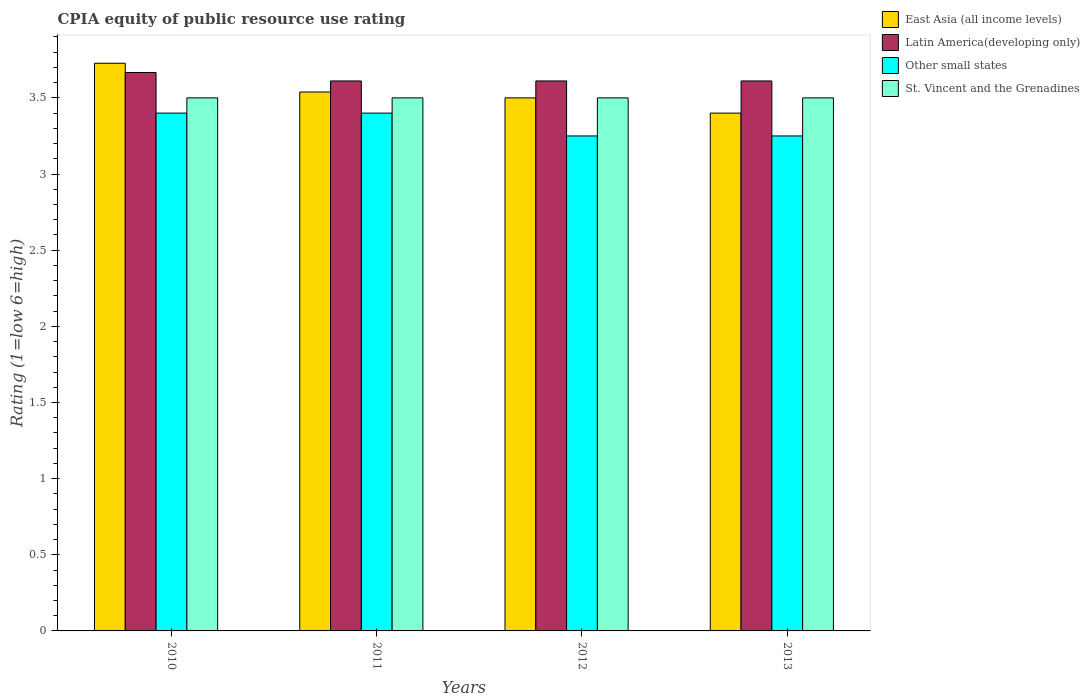How many different coloured bars are there?
Provide a short and direct response. 4. Are the number of bars per tick equal to the number of legend labels?
Provide a succinct answer. Yes. How many bars are there on the 3rd tick from the left?
Make the answer very short. 4. How many bars are there on the 2nd tick from the right?
Provide a short and direct response. 4. What is the CPIA rating in Latin America(developing only) in 2010?
Your response must be concise. 3.67. Across all years, what is the maximum CPIA rating in East Asia (all income levels)?
Provide a short and direct response. 3.73. Across all years, what is the minimum CPIA rating in Other small states?
Offer a very short reply. 3.25. In which year was the CPIA rating in St. Vincent and the Grenadines maximum?
Offer a terse response. 2010. In which year was the CPIA rating in Latin America(developing only) minimum?
Keep it short and to the point. 2011. What is the total CPIA rating in East Asia (all income levels) in the graph?
Ensure brevity in your answer.  14.17. What is the difference between the CPIA rating in St. Vincent and the Grenadines in 2011 and that in 2013?
Offer a terse response. 0. What is the difference between the CPIA rating in Other small states in 2012 and the CPIA rating in Latin America(developing only) in 2013?
Your answer should be very brief. -0.36. What is the average CPIA rating in Latin America(developing only) per year?
Make the answer very short. 3.62. In the year 2013, what is the difference between the CPIA rating in Latin America(developing only) and CPIA rating in East Asia (all income levels)?
Your answer should be compact. 0.21. In how many years, is the CPIA rating in St. Vincent and the Grenadines greater than 3.6?
Keep it short and to the point. 0. Is the CPIA rating in St. Vincent and the Grenadines in 2012 less than that in 2013?
Keep it short and to the point. No. Is the difference between the CPIA rating in Latin America(developing only) in 2011 and 2012 greater than the difference between the CPIA rating in East Asia (all income levels) in 2011 and 2012?
Offer a very short reply. No. What is the difference between the highest and the lowest CPIA rating in East Asia (all income levels)?
Ensure brevity in your answer.  0.33. What does the 4th bar from the left in 2010 represents?
Provide a succinct answer. St. Vincent and the Grenadines. What does the 3rd bar from the right in 2010 represents?
Your answer should be compact. Latin America(developing only). How many bars are there?
Keep it short and to the point. 16. Are all the bars in the graph horizontal?
Your answer should be very brief. No. How many years are there in the graph?
Provide a short and direct response. 4. What is the difference between two consecutive major ticks on the Y-axis?
Give a very brief answer. 0.5. Are the values on the major ticks of Y-axis written in scientific E-notation?
Make the answer very short. No. Does the graph contain any zero values?
Ensure brevity in your answer.  No. Where does the legend appear in the graph?
Your response must be concise. Top right. How many legend labels are there?
Provide a succinct answer. 4. How are the legend labels stacked?
Make the answer very short. Vertical. What is the title of the graph?
Give a very brief answer. CPIA equity of public resource use rating. Does "Turkmenistan" appear as one of the legend labels in the graph?
Your response must be concise. No. What is the label or title of the X-axis?
Offer a terse response. Years. What is the label or title of the Y-axis?
Offer a terse response. Rating (1=low 6=high). What is the Rating (1=low 6=high) in East Asia (all income levels) in 2010?
Provide a short and direct response. 3.73. What is the Rating (1=low 6=high) in Latin America(developing only) in 2010?
Ensure brevity in your answer.  3.67. What is the Rating (1=low 6=high) in Other small states in 2010?
Offer a terse response. 3.4. What is the Rating (1=low 6=high) in East Asia (all income levels) in 2011?
Give a very brief answer. 3.54. What is the Rating (1=low 6=high) of Latin America(developing only) in 2011?
Your answer should be compact. 3.61. What is the Rating (1=low 6=high) in Other small states in 2011?
Your answer should be compact. 3.4. What is the Rating (1=low 6=high) of St. Vincent and the Grenadines in 2011?
Keep it short and to the point. 3.5. What is the Rating (1=low 6=high) of East Asia (all income levels) in 2012?
Provide a succinct answer. 3.5. What is the Rating (1=low 6=high) in Latin America(developing only) in 2012?
Offer a terse response. 3.61. What is the Rating (1=low 6=high) of Other small states in 2012?
Provide a short and direct response. 3.25. What is the Rating (1=low 6=high) of St. Vincent and the Grenadines in 2012?
Give a very brief answer. 3.5. What is the Rating (1=low 6=high) of East Asia (all income levels) in 2013?
Your answer should be compact. 3.4. What is the Rating (1=low 6=high) of Latin America(developing only) in 2013?
Your answer should be compact. 3.61. What is the Rating (1=low 6=high) in Other small states in 2013?
Your answer should be compact. 3.25. What is the Rating (1=low 6=high) of St. Vincent and the Grenadines in 2013?
Offer a very short reply. 3.5. Across all years, what is the maximum Rating (1=low 6=high) of East Asia (all income levels)?
Offer a very short reply. 3.73. Across all years, what is the maximum Rating (1=low 6=high) of Latin America(developing only)?
Your answer should be very brief. 3.67. Across all years, what is the maximum Rating (1=low 6=high) in St. Vincent and the Grenadines?
Your response must be concise. 3.5. Across all years, what is the minimum Rating (1=low 6=high) in Latin America(developing only)?
Offer a terse response. 3.61. Across all years, what is the minimum Rating (1=low 6=high) of St. Vincent and the Grenadines?
Give a very brief answer. 3.5. What is the total Rating (1=low 6=high) of East Asia (all income levels) in the graph?
Offer a terse response. 14.17. What is the total Rating (1=low 6=high) of Latin America(developing only) in the graph?
Your answer should be compact. 14.5. What is the total Rating (1=low 6=high) of St. Vincent and the Grenadines in the graph?
Ensure brevity in your answer.  14. What is the difference between the Rating (1=low 6=high) of East Asia (all income levels) in 2010 and that in 2011?
Make the answer very short. 0.19. What is the difference between the Rating (1=low 6=high) of Latin America(developing only) in 2010 and that in 2011?
Offer a terse response. 0.06. What is the difference between the Rating (1=low 6=high) in Other small states in 2010 and that in 2011?
Keep it short and to the point. 0. What is the difference between the Rating (1=low 6=high) of East Asia (all income levels) in 2010 and that in 2012?
Your answer should be compact. 0.23. What is the difference between the Rating (1=low 6=high) of Latin America(developing only) in 2010 and that in 2012?
Ensure brevity in your answer.  0.06. What is the difference between the Rating (1=low 6=high) of Other small states in 2010 and that in 2012?
Provide a succinct answer. 0.15. What is the difference between the Rating (1=low 6=high) in St. Vincent and the Grenadines in 2010 and that in 2012?
Ensure brevity in your answer.  0. What is the difference between the Rating (1=low 6=high) of East Asia (all income levels) in 2010 and that in 2013?
Your answer should be very brief. 0.33. What is the difference between the Rating (1=low 6=high) of Latin America(developing only) in 2010 and that in 2013?
Your answer should be very brief. 0.06. What is the difference between the Rating (1=low 6=high) in Other small states in 2010 and that in 2013?
Give a very brief answer. 0.15. What is the difference between the Rating (1=low 6=high) of St. Vincent and the Grenadines in 2010 and that in 2013?
Provide a short and direct response. 0. What is the difference between the Rating (1=low 6=high) in East Asia (all income levels) in 2011 and that in 2012?
Provide a short and direct response. 0.04. What is the difference between the Rating (1=low 6=high) of Other small states in 2011 and that in 2012?
Your answer should be compact. 0.15. What is the difference between the Rating (1=low 6=high) of East Asia (all income levels) in 2011 and that in 2013?
Provide a short and direct response. 0.14. What is the difference between the Rating (1=low 6=high) of Latin America(developing only) in 2011 and that in 2013?
Make the answer very short. 0. What is the difference between the Rating (1=low 6=high) of Other small states in 2011 and that in 2013?
Your response must be concise. 0.15. What is the difference between the Rating (1=low 6=high) in St. Vincent and the Grenadines in 2011 and that in 2013?
Offer a very short reply. 0. What is the difference between the Rating (1=low 6=high) in East Asia (all income levels) in 2012 and that in 2013?
Give a very brief answer. 0.1. What is the difference between the Rating (1=low 6=high) of Latin America(developing only) in 2012 and that in 2013?
Provide a succinct answer. 0. What is the difference between the Rating (1=low 6=high) of St. Vincent and the Grenadines in 2012 and that in 2013?
Give a very brief answer. 0. What is the difference between the Rating (1=low 6=high) of East Asia (all income levels) in 2010 and the Rating (1=low 6=high) of Latin America(developing only) in 2011?
Provide a short and direct response. 0.12. What is the difference between the Rating (1=low 6=high) of East Asia (all income levels) in 2010 and the Rating (1=low 6=high) of Other small states in 2011?
Provide a succinct answer. 0.33. What is the difference between the Rating (1=low 6=high) of East Asia (all income levels) in 2010 and the Rating (1=low 6=high) of St. Vincent and the Grenadines in 2011?
Offer a very short reply. 0.23. What is the difference between the Rating (1=low 6=high) in Latin America(developing only) in 2010 and the Rating (1=low 6=high) in Other small states in 2011?
Your response must be concise. 0.27. What is the difference between the Rating (1=low 6=high) in Latin America(developing only) in 2010 and the Rating (1=low 6=high) in St. Vincent and the Grenadines in 2011?
Provide a succinct answer. 0.17. What is the difference between the Rating (1=low 6=high) in Other small states in 2010 and the Rating (1=low 6=high) in St. Vincent and the Grenadines in 2011?
Provide a short and direct response. -0.1. What is the difference between the Rating (1=low 6=high) in East Asia (all income levels) in 2010 and the Rating (1=low 6=high) in Latin America(developing only) in 2012?
Make the answer very short. 0.12. What is the difference between the Rating (1=low 6=high) in East Asia (all income levels) in 2010 and the Rating (1=low 6=high) in Other small states in 2012?
Your answer should be compact. 0.48. What is the difference between the Rating (1=low 6=high) of East Asia (all income levels) in 2010 and the Rating (1=low 6=high) of St. Vincent and the Grenadines in 2012?
Give a very brief answer. 0.23. What is the difference between the Rating (1=low 6=high) of Latin America(developing only) in 2010 and the Rating (1=low 6=high) of Other small states in 2012?
Offer a terse response. 0.42. What is the difference between the Rating (1=low 6=high) in East Asia (all income levels) in 2010 and the Rating (1=low 6=high) in Latin America(developing only) in 2013?
Offer a terse response. 0.12. What is the difference between the Rating (1=low 6=high) of East Asia (all income levels) in 2010 and the Rating (1=low 6=high) of Other small states in 2013?
Your answer should be very brief. 0.48. What is the difference between the Rating (1=low 6=high) of East Asia (all income levels) in 2010 and the Rating (1=low 6=high) of St. Vincent and the Grenadines in 2013?
Offer a terse response. 0.23. What is the difference between the Rating (1=low 6=high) of Latin America(developing only) in 2010 and the Rating (1=low 6=high) of Other small states in 2013?
Your answer should be compact. 0.42. What is the difference between the Rating (1=low 6=high) of East Asia (all income levels) in 2011 and the Rating (1=low 6=high) of Latin America(developing only) in 2012?
Provide a succinct answer. -0.07. What is the difference between the Rating (1=low 6=high) in East Asia (all income levels) in 2011 and the Rating (1=low 6=high) in Other small states in 2012?
Ensure brevity in your answer.  0.29. What is the difference between the Rating (1=low 6=high) in East Asia (all income levels) in 2011 and the Rating (1=low 6=high) in St. Vincent and the Grenadines in 2012?
Offer a very short reply. 0.04. What is the difference between the Rating (1=low 6=high) of Latin America(developing only) in 2011 and the Rating (1=low 6=high) of Other small states in 2012?
Keep it short and to the point. 0.36. What is the difference between the Rating (1=low 6=high) of East Asia (all income levels) in 2011 and the Rating (1=low 6=high) of Latin America(developing only) in 2013?
Your answer should be compact. -0.07. What is the difference between the Rating (1=low 6=high) of East Asia (all income levels) in 2011 and the Rating (1=low 6=high) of Other small states in 2013?
Offer a very short reply. 0.29. What is the difference between the Rating (1=low 6=high) in East Asia (all income levels) in 2011 and the Rating (1=low 6=high) in St. Vincent and the Grenadines in 2013?
Your answer should be compact. 0.04. What is the difference between the Rating (1=low 6=high) in Latin America(developing only) in 2011 and the Rating (1=low 6=high) in Other small states in 2013?
Keep it short and to the point. 0.36. What is the difference between the Rating (1=low 6=high) in Latin America(developing only) in 2011 and the Rating (1=low 6=high) in St. Vincent and the Grenadines in 2013?
Offer a terse response. 0.11. What is the difference between the Rating (1=low 6=high) in Other small states in 2011 and the Rating (1=low 6=high) in St. Vincent and the Grenadines in 2013?
Offer a terse response. -0.1. What is the difference between the Rating (1=low 6=high) of East Asia (all income levels) in 2012 and the Rating (1=low 6=high) of Latin America(developing only) in 2013?
Keep it short and to the point. -0.11. What is the difference between the Rating (1=low 6=high) in Latin America(developing only) in 2012 and the Rating (1=low 6=high) in Other small states in 2013?
Give a very brief answer. 0.36. What is the difference between the Rating (1=low 6=high) in Latin America(developing only) in 2012 and the Rating (1=low 6=high) in St. Vincent and the Grenadines in 2013?
Ensure brevity in your answer.  0.11. What is the difference between the Rating (1=low 6=high) in Other small states in 2012 and the Rating (1=low 6=high) in St. Vincent and the Grenadines in 2013?
Make the answer very short. -0.25. What is the average Rating (1=low 6=high) in East Asia (all income levels) per year?
Provide a succinct answer. 3.54. What is the average Rating (1=low 6=high) of Latin America(developing only) per year?
Your response must be concise. 3.62. What is the average Rating (1=low 6=high) in Other small states per year?
Give a very brief answer. 3.33. In the year 2010, what is the difference between the Rating (1=low 6=high) in East Asia (all income levels) and Rating (1=low 6=high) in Latin America(developing only)?
Ensure brevity in your answer.  0.06. In the year 2010, what is the difference between the Rating (1=low 6=high) of East Asia (all income levels) and Rating (1=low 6=high) of Other small states?
Ensure brevity in your answer.  0.33. In the year 2010, what is the difference between the Rating (1=low 6=high) in East Asia (all income levels) and Rating (1=low 6=high) in St. Vincent and the Grenadines?
Keep it short and to the point. 0.23. In the year 2010, what is the difference between the Rating (1=low 6=high) in Latin America(developing only) and Rating (1=low 6=high) in Other small states?
Offer a terse response. 0.27. In the year 2011, what is the difference between the Rating (1=low 6=high) of East Asia (all income levels) and Rating (1=low 6=high) of Latin America(developing only)?
Your answer should be compact. -0.07. In the year 2011, what is the difference between the Rating (1=low 6=high) of East Asia (all income levels) and Rating (1=low 6=high) of Other small states?
Your answer should be compact. 0.14. In the year 2011, what is the difference between the Rating (1=low 6=high) of East Asia (all income levels) and Rating (1=low 6=high) of St. Vincent and the Grenadines?
Provide a succinct answer. 0.04. In the year 2011, what is the difference between the Rating (1=low 6=high) of Latin America(developing only) and Rating (1=low 6=high) of Other small states?
Offer a very short reply. 0.21. In the year 2011, what is the difference between the Rating (1=low 6=high) in Latin America(developing only) and Rating (1=low 6=high) in St. Vincent and the Grenadines?
Offer a terse response. 0.11. In the year 2012, what is the difference between the Rating (1=low 6=high) in East Asia (all income levels) and Rating (1=low 6=high) in Latin America(developing only)?
Offer a very short reply. -0.11. In the year 2012, what is the difference between the Rating (1=low 6=high) in East Asia (all income levels) and Rating (1=low 6=high) in Other small states?
Give a very brief answer. 0.25. In the year 2012, what is the difference between the Rating (1=low 6=high) of Latin America(developing only) and Rating (1=low 6=high) of Other small states?
Give a very brief answer. 0.36. In the year 2012, what is the difference between the Rating (1=low 6=high) of Latin America(developing only) and Rating (1=low 6=high) of St. Vincent and the Grenadines?
Offer a terse response. 0.11. In the year 2012, what is the difference between the Rating (1=low 6=high) of Other small states and Rating (1=low 6=high) of St. Vincent and the Grenadines?
Give a very brief answer. -0.25. In the year 2013, what is the difference between the Rating (1=low 6=high) of East Asia (all income levels) and Rating (1=low 6=high) of Latin America(developing only)?
Offer a very short reply. -0.21. In the year 2013, what is the difference between the Rating (1=low 6=high) of East Asia (all income levels) and Rating (1=low 6=high) of Other small states?
Give a very brief answer. 0.15. In the year 2013, what is the difference between the Rating (1=low 6=high) of Latin America(developing only) and Rating (1=low 6=high) of Other small states?
Offer a very short reply. 0.36. What is the ratio of the Rating (1=low 6=high) in East Asia (all income levels) in 2010 to that in 2011?
Offer a very short reply. 1.05. What is the ratio of the Rating (1=low 6=high) of Latin America(developing only) in 2010 to that in 2011?
Provide a succinct answer. 1.02. What is the ratio of the Rating (1=low 6=high) in Other small states in 2010 to that in 2011?
Your response must be concise. 1. What is the ratio of the Rating (1=low 6=high) of East Asia (all income levels) in 2010 to that in 2012?
Provide a short and direct response. 1.06. What is the ratio of the Rating (1=low 6=high) of Latin America(developing only) in 2010 to that in 2012?
Provide a succinct answer. 1.02. What is the ratio of the Rating (1=low 6=high) in Other small states in 2010 to that in 2012?
Keep it short and to the point. 1.05. What is the ratio of the Rating (1=low 6=high) of St. Vincent and the Grenadines in 2010 to that in 2012?
Offer a very short reply. 1. What is the ratio of the Rating (1=low 6=high) of East Asia (all income levels) in 2010 to that in 2013?
Make the answer very short. 1.1. What is the ratio of the Rating (1=low 6=high) of Latin America(developing only) in 2010 to that in 2013?
Your answer should be very brief. 1.02. What is the ratio of the Rating (1=low 6=high) of Other small states in 2010 to that in 2013?
Your answer should be compact. 1.05. What is the ratio of the Rating (1=low 6=high) in St. Vincent and the Grenadines in 2010 to that in 2013?
Your answer should be compact. 1. What is the ratio of the Rating (1=low 6=high) in Latin America(developing only) in 2011 to that in 2012?
Make the answer very short. 1. What is the ratio of the Rating (1=low 6=high) of Other small states in 2011 to that in 2012?
Provide a short and direct response. 1.05. What is the ratio of the Rating (1=low 6=high) of East Asia (all income levels) in 2011 to that in 2013?
Your answer should be very brief. 1.04. What is the ratio of the Rating (1=low 6=high) of Other small states in 2011 to that in 2013?
Your answer should be compact. 1.05. What is the ratio of the Rating (1=low 6=high) of East Asia (all income levels) in 2012 to that in 2013?
Keep it short and to the point. 1.03. What is the ratio of the Rating (1=low 6=high) of Other small states in 2012 to that in 2013?
Your response must be concise. 1. What is the difference between the highest and the second highest Rating (1=low 6=high) in East Asia (all income levels)?
Give a very brief answer. 0.19. What is the difference between the highest and the second highest Rating (1=low 6=high) of Latin America(developing only)?
Your answer should be compact. 0.06. What is the difference between the highest and the second highest Rating (1=low 6=high) in Other small states?
Ensure brevity in your answer.  0. What is the difference between the highest and the second highest Rating (1=low 6=high) in St. Vincent and the Grenadines?
Provide a short and direct response. 0. What is the difference between the highest and the lowest Rating (1=low 6=high) in East Asia (all income levels)?
Make the answer very short. 0.33. What is the difference between the highest and the lowest Rating (1=low 6=high) in Latin America(developing only)?
Your answer should be very brief. 0.06. 